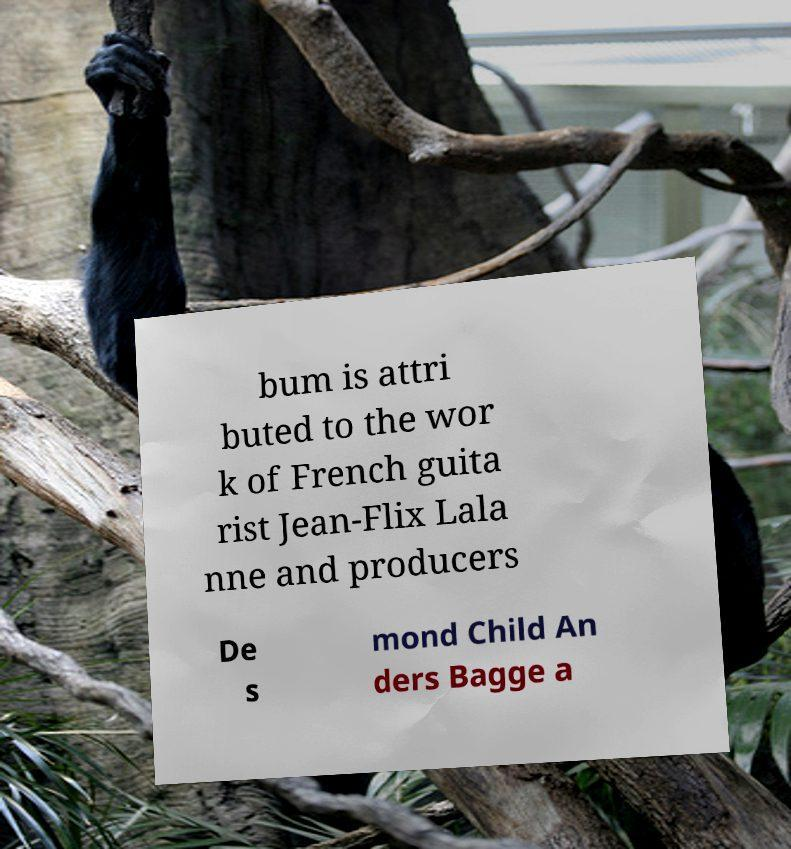Please read and relay the text visible in this image. What does it say? bum is attri buted to the wor k of French guita rist Jean-Flix Lala nne and producers De s mond Child An ders Bagge a 